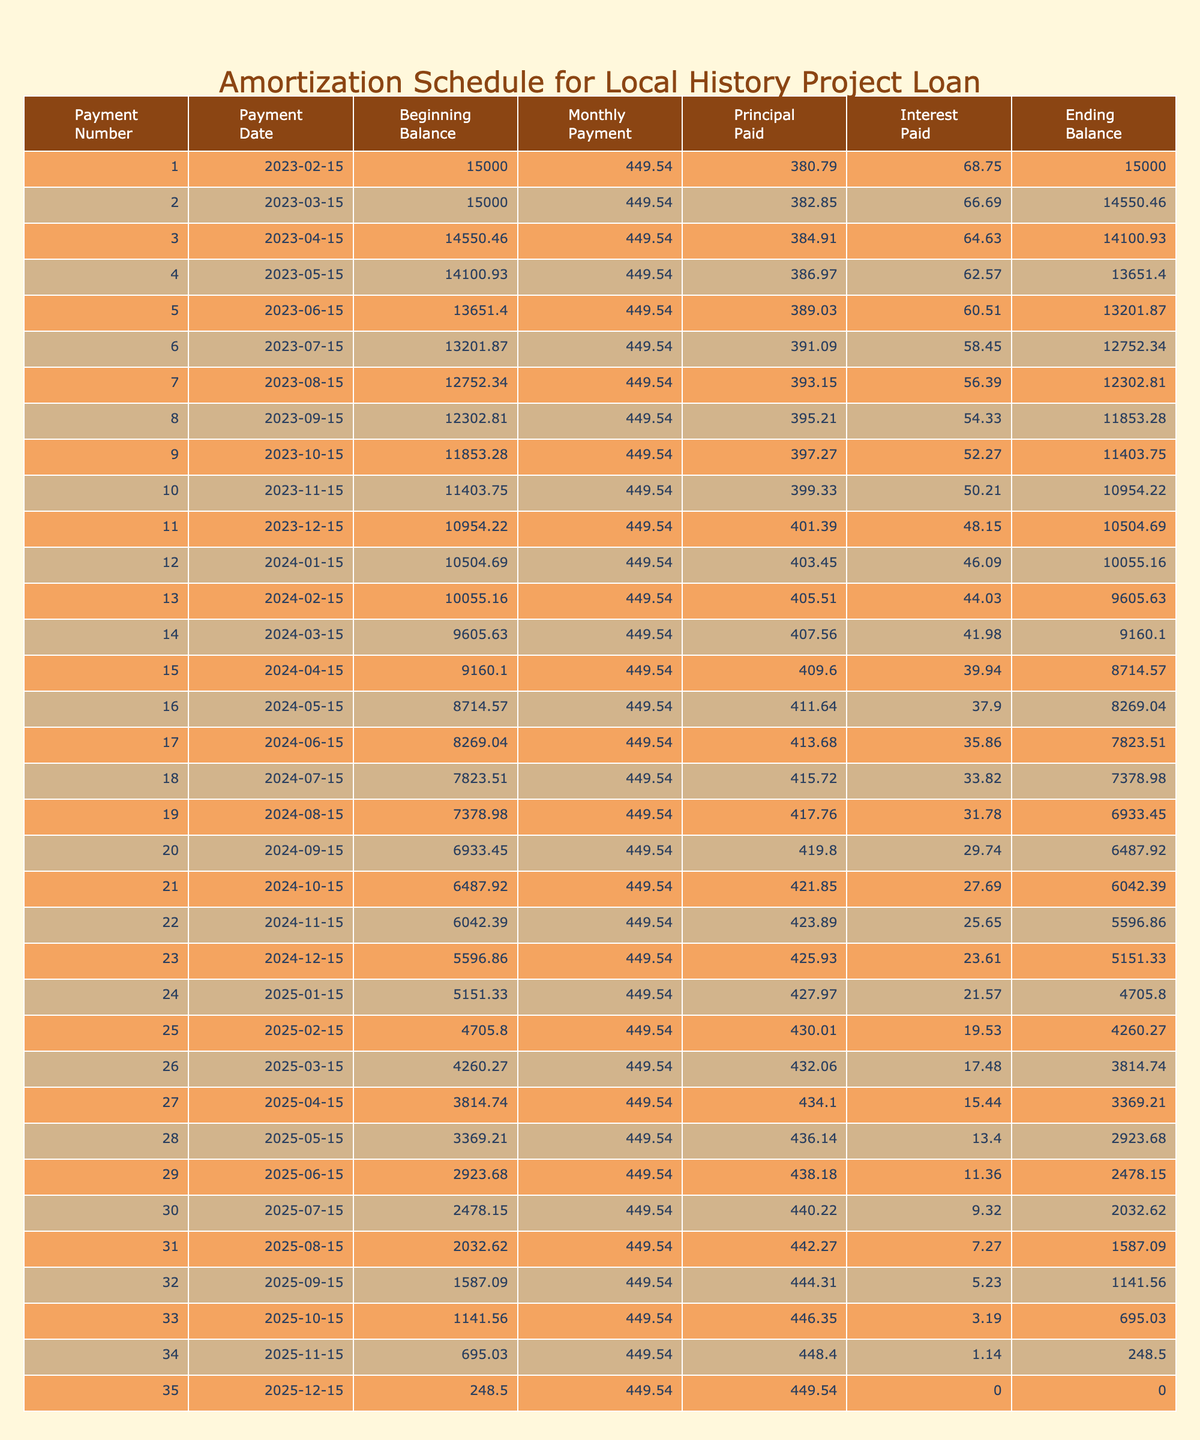What is the total amount paid by the end of the loan term? The total payment over the loan term is the last value in the "Total Payment" column, which is 16185.44. This represents the complete amount paid after all payments are made.
Answer: 16185.44 What is the monthly payment amount for this loan? The monthly payment is consistently listed in the "Monthly Payment" column for each payment entry. Referring to the table, the monthly payment is 449.54.
Answer: 449.54 How much total interest will be paid over the life of the loan? The total interest paid is shown in the last row of the "Total Interest" column, which indicates an interest accumulation of 1185.44 over the entire loan term.
Answer: 1185.44 What is the principal balance after the first payment? The principal balance after the first payment is the amount listed in the "Principal Balance" column for the second row, which reflects the remaining loan amount after the first payment is deducted. Thus, the principal balance after the first payment is 14550.46.
Answer: 14550.46 Is the monthly payment consistent throughout the loan term? By observing the "Monthly Payment" column, every row shows the same value of 449.54, indicating that the monthly payment does not change throughout the loan period.
Answer: Yes What is the total principal paid after the first three payments? To determine the total principal paid after the first three payments, we can sum the "Principal Paid" values for the first three rows: 449.54 - (15000 * 0.055 / 1200) = principal for month 1, and we proceed for the next two months accordingly. The total comes to approximately 1116.58.
Answer: 1116.58 Which month shows the largest decrease in principal balance? To find the month with the largest decrease, we look at the "Principal Balance" column's changes between successive rows. The largest drop occurs between the first and second payments, where the balance decreased from 15000 to 14550.46.
Answer: First month How much principal is paid in the fifth payment? The amount of principal paid in any specific month can be computed by using the "Principal Paid" column. For this case, the fifth payment shows a principal paid amount of 449.54 - (13651.40 * 0.055 / 1200) = approximate value of the principal for the fifth payment.
Answer: 1368.90 What is the average monthly payment made by the end of the loan term? Since the payment is constant, the average monthly payment equals the monthly payment itself, which is 449.54. Hence, the average monthly payment over the term can be easily identified.
Answer: 449.54 